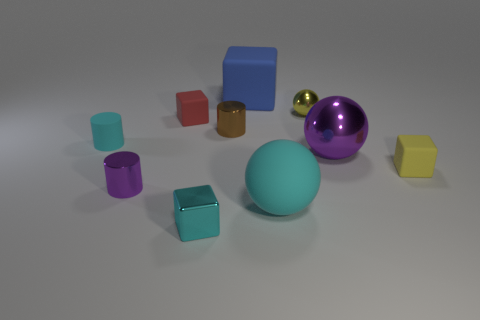What is the material of the small block that is the same color as the rubber cylinder?
Your answer should be compact. Metal. There is another ball that is the same size as the purple shiny sphere; what material is it?
Give a very brief answer. Rubber. Is the size of the purple object that is to the right of the big blue rubber thing the same as the purple object that is left of the brown metallic cylinder?
Give a very brief answer. No. There is a small cyan cylinder; are there any cyan rubber objects behind it?
Your response must be concise. No. The block that is on the right side of the big rubber thing behind the purple shiny cylinder is what color?
Provide a succinct answer. Yellow. Are there fewer blue blocks than blue metallic blocks?
Ensure brevity in your answer.  No. What number of big metal objects are the same shape as the tiny yellow shiny thing?
Your response must be concise. 1. There is a ball that is the same size as the brown cylinder; what color is it?
Keep it short and to the point. Yellow. Is the number of big cyan matte spheres that are to the left of the cyan metallic object the same as the number of small purple cylinders in front of the yellow ball?
Ensure brevity in your answer.  No. Are there any red spheres that have the same size as the blue object?
Keep it short and to the point. No. 